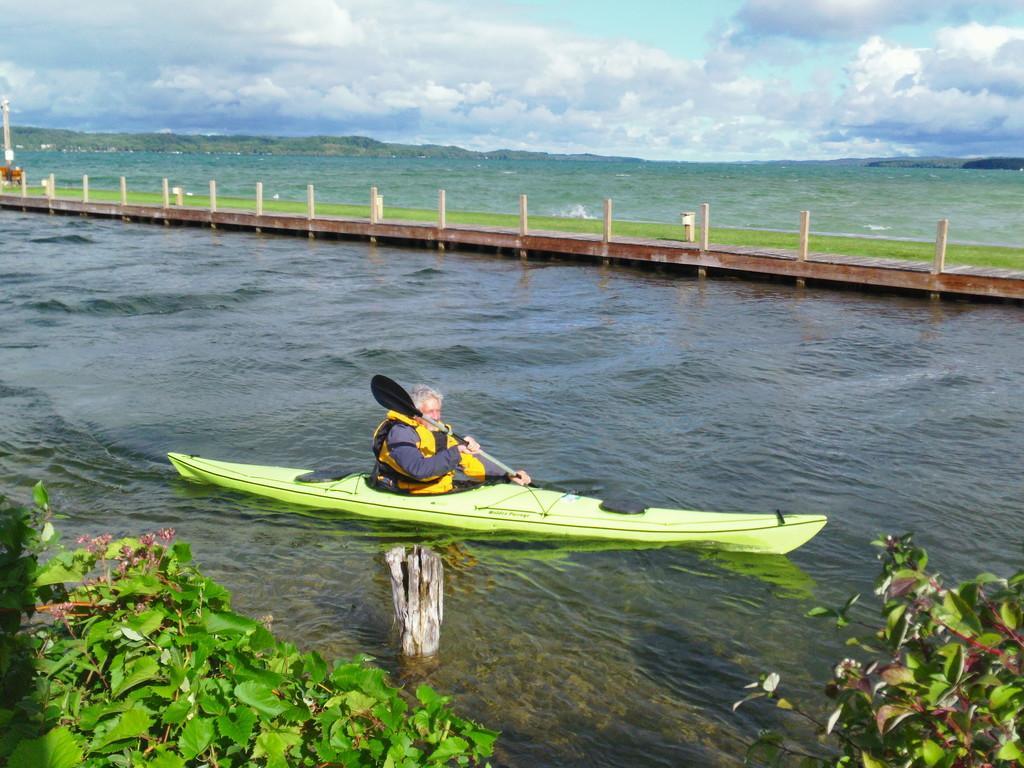In one or two sentences, can you explain what this image depicts? This image is taken outdoors. At the top of the image there is the sky with clouds. At the bottom of the image there are a few plants. In the background there are a few hills. In the middle of the image there is a river with water and there is a bridge with a fence. A man is sailing a boat on the river. He is sitting in the boat and he is holding a boat pad in his hands. 